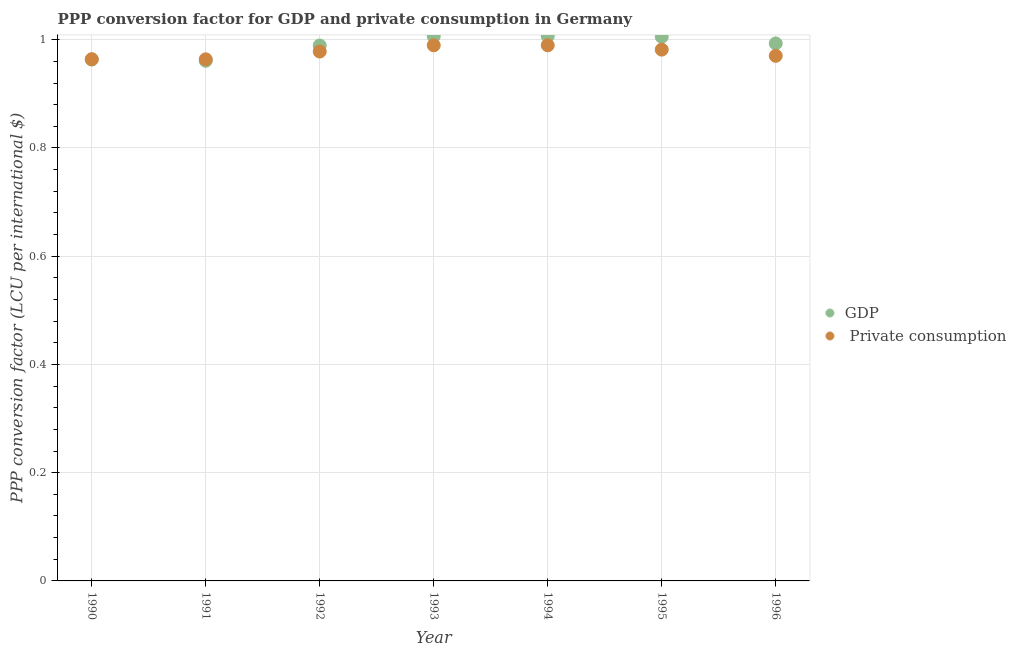How many different coloured dotlines are there?
Make the answer very short. 2. Is the number of dotlines equal to the number of legend labels?
Offer a terse response. Yes. What is the ppp conversion factor for private consumption in 1990?
Ensure brevity in your answer.  0.96. Across all years, what is the maximum ppp conversion factor for private consumption?
Offer a very short reply. 0.99. Across all years, what is the minimum ppp conversion factor for gdp?
Your response must be concise. 0.96. In which year was the ppp conversion factor for gdp maximum?
Provide a succinct answer. 1994. What is the total ppp conversion factor for gdp in the graph?
Your answer should be very brief. 6.93. What is the difference between the ppp conversion factor for private consumption in 1990 and that in 1996?
Provide a succinct answer. -0.01. What is the difference between the ppp conversion factor for private consumption in 1994 and the ppp conversion factor for gdp in 1990?
Offer a very short reply. 0.03. What is the average ppp conversion factor for gdp per year?
Ensure brevity in your answer.  0.99. In the year 1991, what is the difference between the ppp conversion factor for gdp and ppp conversion factor for private consumption?
Provide a succinct answer. -0. In how many years, is the ppp conversion factor for gdp greater than 0.6400000000000001 LCU?
Give a very brief answer. 7. What is the ratio of the ppp conversion factor for gdp in 1991 to that in 1993?
Offer a very short reply. 0.96. Is the difference between the ppp conversion factor for private consumption in 1993 and 1996 greater than the difference between the ppp conversion factor for gdp in 1993 and 1996?
Provide a succinct answer. Yes. What is the difference between the highest and the second highest ppp conversion factor for gdp?
Give a very brief answer. 0. What is the difference between the highest and the lowest ppp conversion factor for private consumption?
Offer a terse response. 0.03. In how many years, is the ppp conversion factor for gdp greater than the average ppp conversion factor for gdp taken over all years?
Give a very brief answer. 5. Does the ppp conversion factor for gdp monotonically increase over the years?
Provide a short and direct response. No. Is the ppp conversion factor for private consumption strictly greater than the ppp conversion factor for gdp over the years?
Keep it short and to the point. No. How many dotlines are there?
Keep it short and to the point. 2. How many years are there in the graph?
Provide a succinct answer. 7. Are the values on the major ticks of Y-axis written in scientific E-notation?
Make the answer very short. No. Does the graph contain any zero values?
Your answer should be very brief. No. Does the graph contain grids?
Your answer should be compact. Yes. How many legend labels are there?
Your answer should be very brief. 2. What is the title of the graph?
Your response must be concise. PPP conversion factor for GDP and private consumption in Germany. Does "Birth rate" appear as one of the legend labels in the graph?
Your answer should be very brief. No. What is the label or title of the X-axis?
Offer a terse response. Year. What is the label or title of the Y-axis?
Your answer should be compact. PPP conversion factor (LCU per international $). What is the PPP conversion factor (LCU per international $) in GDP in 1990?
Keep it short and to the point. 0.96. What is the PPP conversion factor (LCU per international $) of  Private consumption in 1990?
Make the answer very short. 0.96. What is the PPP conversion factor (LCU per international $) of GDP in 1991?
Keep it short and to the point. 0.96. What is the PPP conversion factor (LCU per international $) in  Private consumption in 1991?
Your answer should be very brief. 0.96. What is the PPP conversion factor (LCU per international $) in GDP in 1992?
Your answer should be very brief. 0.99. What is the PPP conversion factor (LCU per international $) of  Private consumption in 1992?
Your answer should be compact. 0.98. What is the PPP conversion factor (LCU per international $) of GDP in 1993?
Provide a short and direct response. 1.01. What is the PPP conversion factor (LCU per international $) in  Private consumption in 1993?
Make the answer very short. 0.99. What is the PPP conversion factor (LCU per international $) in GDP in 1994?
Make the answer very short. 1.01. What is the PPP conversion factor (LCU per international $) in  Private consumption in 1994?
Provide a short and direct response. 0.99. What is the PPP conversion factor (LCU per international $) of GDP in 1995?
Give a very brief answer. 1.01. What is the PPP conversion factor (LCU per international $) of  Private consumption in 1995?
Your answer should be very brief. 0.98. What is the PPP conversion factor (LCU per international $) of GDP in 1996?
Make the answer very short. 0.99. What is the PPP conversion factor (LCU per international $) in  Private consumption in 1996?
Offer a very short reply. 0.97. Across all years, what is the maximum PPP conversion factor (LCU per international $) in GDP?
Offer a very short reply. 1.01. Across all years, what is the maximum PPP conversion factor (LCU per international $) in  Private consumption?
Give a very brief answer. 0.99. Across all years, what is the minimum PPP conversion factor (LCU per international $) of GDP?
Offer a very short reply. 0.96. Across all years, what is the minimum PPP conversion factor (LCU per international $) of  Private consumption?
Offer a very short reply. 0.96. What is the total PPP conversion factor (LCU per international $) in GDP in the graph?
Offer a very short reply. 6.93. What is the total PPP conversion factor (LCU per international $) in  Private consumption in the graph?
Provide a short and direct response. 6.84. What is the difference between the PPP conversion factor (LCU per international $) of GDP in 1990 and that in 1991?
Provide a succinct answer. 0. What is the difference between the PPP conversion factor (LCU per international $) of GDP in 1990 and that in 1992?
Ensure brevity in your answer.  -0.03. What is the difference between the PPP conversion factor (LCU per international $) of  Private consumption in 1990 and that in 1992?
Your answer should be very brief. -0.01. What is the difference between the PPP conversion factor (LCU per international $) in GDP in 1990 and that in 1993?
Give a very brief answer. -0.04. What is the difference between the PPP conversion factor (LCU per international $) of  Private consumption in 1990 and that in 1993?
Make the answer very short. -0.03. What is the difference between the PPP conversion factor (LCU per international $) in GDP in 1990 and that in 1994?
Provide a succinct answer. -0.04. What is the difference between the PPP conversion factor (LCU per international $) of  Private consumption in 1990 and that in 1994?
Keep it short and to the point. -0.03. What is the difference between the PPP conversion factor (LCU per international $) in GDP in 1990 and that in 1995?
Offer a very short reply. -0.04. What is the difference between the PPP conversion factor (LCU per international $) of  Private consumption in 1990 and that in 1995?
Offer a terse response. -0.02. What is the difference between the PPP conversion factor (LCU per international $) in GDP in 1990 and that in 1996?
Your answer should be very brief. -0.03. What is the difference between the PPP conversion factor (LCU per international $) of  Private consumption in 1990 and that in 1996?
Provide a succinct answer. -0.01. What is the difference between the PPP conversion factor (LCU per international $) of GDP in 1991 and that in 1992?
Your answer should be very brief. -0.03. What is the difference between the PPP conversion factor (LCU per international $) of  Private consumption in 1991 and that in 1992?
Make the answer very short. -0.01. What is the difference between the PPP conversion factor (LCU per international $) of GDP in 1991 and that in 1993?
Make the answer very short. -0.05. What is the difference between the PPP conversion factor (LCU per international $) in  Private consumption in 1991 and that in 1993?
Your answer should be very brief. -0.03. What is the difference between the PPP conversion factor (LCU per international $) in GDP in 1991 and that in 1994?
Keep it short and to the point. -0.05. What is the difference between the PPP conversion factor (LCU per international $) of  Private consumption in 1991 and that in 1994?
Make the answer very short. -0.03. What is the difference between the PPP conversion factor (LCU per international $) of GDP in 1991 and that in 1995?
Give a very brief answer. -0.04. What is the difference between the PPP conversion factor (LCU per international $) of  Private consumption in 1991 and that in 1995?
Keep it short and to the point. -0.02. What is the difference between the PPP conversion factor (LCU per international $) of GDP in 1991 and that in 1996?
Offer a terse response. -0.03. What is the difference between the PPP conversion factor (LCU per international $) in  Private consumption in 1991 and that in 1996?
Offer a very short reply. -0.01. What is the difference between the PPP conversion factor (LCU per international $) of GDP in 1992 and that in 1993?
Give a very brief answer. -0.02. What is the difference between the PPP conversion factor (LCU per international $) of  Private consumption in 1992 and that in 1993?
Provide a succinct answer. -0.01. What is the difference between the PPP conversion factor (LCU per international $) in GDP in 1992 and that in 1994?
Give a very brief answer. -0.02. What is the difference between the PPP conversion factor (LCU per international $) of  Private consumption in 1992 and that in 1994?
Your response must be concise. -0.01. What is the difference between the PPP conversion factor (LCU per international $) of GDP in 1992 and that in 1995?
Provide a succinct answer. -0.02. What is the difference between the PPP conversion factor (LCU per international $) in  Private consumption in 1992 and that in 1995?
Provide a short and direct response. -0. What is the difference between the PPP conversion factor (LCU per international $) of GDP in 1992 and that in 1996?
Offer a terse response. -0. What is the difference between the PPP conversion factor (LCU per international $) in  Private consumption in 1992 and that in 1996?
Give a very brief answer. 0.01. What is the difference between the PPP conversion factor (LCU per international $) of GDP in 1993 and that in 1994?
Give a very brief answer. -0. What is the difference between the PPP conversion factor (LCU per international $) of  Private consumption in 1993 and that in 1994?
Offer a very short reply. -0. What is the difference between the PPP conversion factor (LCU per international $) of GDP in 1993 and that in 1995?
Offer a very short reply. 0. What is the difference between the PPP conversion factor (LCU per international $) of  Private consumption in 1993 and that in 1995?
Provide a short and direct response. 0.01. What is the difference between the PPP conversion factor (LCU per international $) in GDP in 1993 and that in 1996?
Ensure brevity in your answer.  0.01. What is the difference between the PPP conversion factor (LCU per international $) of  Private consumption in 1993 and that in 1996?
Your answer should be very brief. 0.02. What is the difference between the PPP conversion factor (LCU per international $) of GDP in 1994 and that in 1995?
Offer a terse response. 0. What is the difference between the PPP conversion factor (LCU per international $) of  Private consumption in 1994 and that in 1995?
Give a very brief answer. 0.01. What is the difference between the PPP conversion factor (LCU per international $) of GDP in 1994 and that in 1996?
Offer a very short reply. 0.01. What is the difference between the PPP conversion factor (LCU per international $) in  Private consumption in 1994 and that in 1996?
Offer a terse response. 0.02. What is the difference between the PPP conversion factor (LCU per international $) of GDP in 1995 and that in 1996?
Ensure brevity in your answer.  0.01. What is the difference between the PPP conversion factor (LCU per international $) of  Private consumption in 1995 and that in 1996?
Make the answer very short. 0.01. What is the difference between the PPP conversion factor (LCU per international $) in GDP in 1990 and the PPP conversion factor (LCU per international $) in  Private consumption in 1991?
Ensure brevity in your answer.  -0. What is the difference between the PPP conversion factor (LCU per international $) in GDP in 1990 and the PPP conversion factor (LCU per international $) in  Private consumption in 1992?
Offer a very short reply. -0.01. What is the difference between the PPP conversion factor (LCU per international $) of GDP in 1990 and the PPP conversion factor (LCU per international $) of  Private consumption in 1993?
Give a very brief answer. -0.03. What is the difference between the PPP conversion factor (LCU per international $) in GDP in 1990 and the PPP conversion factor (LCU per international $) in  Private consumption in 1994?
Keep it short and to the point. -0.03. What is the difference between the PPP conversion factor (LCU per international $) of GDP in 1990 and the PPP conversion factor (LCU per international $) of  Private consumption in 1995?
Provide a succinct answer. -0.02. What is the difference between the PPP conversion factor (LCU per international $) in GDP in 1990 and the PPP conversion factor (LCU per international $) in  Private consumption in 1996?
Give a very brief answer. -0.01. What is the difference between the PPP conversion factor (LCU per international $) of GDP in 1991 and the PPP conversion factor (LCU per international $) of  Private consumption in 1992?
Your response must be concise. -0.02. What is the difference between the PPP conversion factor (LCU per international $) of GDP in 1991 and the PPP conversion factor (LCU per international $) of  Private consumption in 1993?
Offer a very short reply. -0.03. What is the difference between the PPP conversion factor (LCU per international $) in GDP in 1991 and the PPP conversion factor (LCU per international $) in  Private consumption in 1994?
Give a very brief answer. -0.03. What is the difference between the PPP conversion factor (LCU per international $) of GDP in 1991 and the PPP conversion factor (LCU per international $) of  Private consumption in 1995?
Make the answer very short. -0.02. What is the difference between the PPP conversion factor (LCU per international $) in GDP in 1991 and the PPP conversion factor (LCU per international $) in  Private consumption in 1996?
Your answer should be very brief. -0.01. What is the difference between the PPP conversion factor (LCU per international $) of GDP in 1992 and the PPP conversion factor (LCU per international $) of  Private consumption in 1993?
Your answer should be compact. -0. What is the difference between the PPP conversion factor (LCU per international $) of GDP in 1992 and the PPP conversion factor (LCU per international $) of  Private consumption in 1994?
Your response must be concise. -0. What is the difference between the PPP conversion factor (LCU per international $) of GDP in 1992 and the PPP conversion factor (LCU per international $) of  Private consumption in 1995?
Make the answer very short. 0.01. What is the difference between the PPP conversion factor (LCU per international $) in GDP in 1992 and the PPP conversion factor (LCU per international $) in  Private consumption in 1996?
Make the answer very short. 0.02. What is the difference between the PPP conversion factor (LCU per international $) of GDP in 1993 and the PPP conversion factor (LCU per international $) of  Private consumption in 1994?
Offer a terse response. 0.02. What is the difference between the PPP conversion factor (LCU per international $) of GDP in 1993 and the PPP conversion factor (LCU per international $) of  Private consumption in 1995?
Ensure brevity in your answer.  0.02. What is the difference between the PPP conversion factor (LCU per international $) of GDP in 1993 and the PPP conversion factor (LCU per international $) of  Private consumption in 1996?
Your answer should be very brief. 0.04. What is the difference between the PPP conversion factor (LCU per international $) in GDP in 1994 and the PPP conversion factor (LCU per international $) in  Private consumption in 1995?
Ensure brevity in your answer.  0.03. What is the difference between the PPP conversion factor (LCU per international $) in GDP in 1994 and the PPP conversion factor (LCU per international $) in  Private consumption in 1996?
Your answer should be compact. 0.04. What is the difference between the PPP conversion factor (LCU per international $) of GDP in 1995 and the PPP conversion factor (LCU per international $) of  Private consumption in 1996?
Your answer should be compact. 0.04. What is the average PPP conversion factor (LCU per international $) in GDP per year?
Your response must be concise. 0.99. What is the average PPP conversion factor (LCU per international $) in  Private consumption per year?
Ensure brevity in your answer.  0.98. In the year 1990, what is the difference between the PPP conversion factor (LCU per international $) of GDP and PPP conversion factor (LCU per international $) of  Private consumption?
Your response must be concise. -0. In the year 1991, what is the difference between the PPP conversion factor (LCU per international $) in GDP and PPP conversion factor (LCU per international $) in  Private consumption?
Your response must be concise. -0. In the year 1992, what is the difference between the PPP conversion factor (LCU per international $) in GDP and PPP conversion factor (LCU per international $) in  Private consumption?
Your response must be concise. 0.01. In the year 1993, what is the difference between the PPP conversion factor (LCU per international $) of GDP and PPP conversion factor (LCU per international $) of  Private consumption?
Your response must be concise. 0.02. In the year 1994, what is the difference between the PPP conversion factor (LCU per international $) of GDP and PPP conversion factor (LCU per international $) of  Private consumption?
Offer a very short reply. 0.02. In the year 1995, what is the difference between the PPP conversion factor (LCU per international $) in GDP and PPP conversion factor (LCU per international $) in  Private consumption?
Ensure brevity in your answer.  0.02. In the year 1996, what is the difference between the PPP conversion factor (LCU per international $) in GDP and PPP conversion factor (LCU per international $) in  Private consumption?
Provide a succinct answer. 0.02. What is the ratio of the PPP conversion factor (LCU per international $) in GDP in 1990 to that in 1991?
Ensure brevity in your answer.  1. What is the ratio of the PPP conversion factor (LCU per international $) in  Private consumption in 1990 to that in 1991?
Keep it short and to the point. 1. What is the ratio of the PPP conversion factor (LCU per international $) of GDP in 1990 to that in 1992?
Make the answer very short. 0.97. What is the ratio of the PPP conversion factor (LCU per international $) of  Private consumption in 1990 to that in 1992?
Your answer should be compact. 0.99. What is the ratio of the PPP conversion factor (LCU per international $) of GDP in 1990 to that in 1993?
Your response must be concise. 0.96. What is the ratio of the PPP conversion factor (LCU per international $) in  Private consumption in 1990 to that in 1993?
Your answer should be very brief. 0.97. What is the ratio of the PPP conversion factor (LCU per international $) in GDP in 1990 to that in 1994?
Your response must be concise. 0.96. What is the ratio of the PPP conversion factor (LCU per international $) in GDP in 1990 to that in 1995?
Provide a succinct answer. 0.96. What is the ratio of the PPP conversion factor (LCU per international $) of  Private consumption in 1990 to that in 1995?
Ensure brevity in your answer.  0.98. What is the ratio of the PPP conversion factor (LCU per international $) in GDP in 1990 to that in 1996?
Provide a short and direct response. 0.97. What is the ratio of the PPP conversion factor (LCU per international $) of GDP in 1991 to that in 1992?
Your response must be concise. 0.97. What is the ratio of the PPP conversion factor (LCU per international $) in GDP in 1991 to that in 1993?
Offer a terse response. 0.95. What is the ratio of the PPP conversion factor (LCU per international $) of  Private consumption in 1991 to that in 1993?
Offer a terse response. 0.97. What is the ratio of the PPP conversion factor (LCU per international $) in GDP in 1991 to that in 1994?
Make the answer very short. 0.95. What is the ratio of the PPP conversion factor (LCU per international $) in  Private consumption in 1991 to that in 1994?
Offer a terse response. 0.97. What is the ratio of the PPP conversion factor (LCU per international $) in GDP in 1991 to that in 1995?
Provide a short and direct response. 0.96. What is the ratio of the PPP conversion factor (LCU per international $) of  Private consumption in 1991 to that in 1995?
Keep it short and to the point. 0.98. What is the ratio of the PPP conversion factor (LCU per international $) of GDP in 1991 to that in 1996?
Ensure brevity in your answer.  0.97. What is the ratio of the PPP conversion factor (LCU per international $) of GDP in 1992 to that in 1993?
Offer a terse response. 0.98. What is the ratio of the PPP conversion factor (LCU per international $) in  Private consumption in 1992 to that in 1993?
Offer a terse response. 0.99. What is the ratio of the PPP conversion factor (LCU per international $) in GDP in 1992 to that in 1994?
Provide a short and direct response. 0.98. What is the ratio of the PPP conversion factor (LCU per international $) in  Private consumption in 1992 to that in 1994?
Provide a succinct answer. 0.99. What is the ratio of the PPP conversion factor (LCU per international $) in GDP in 1992 to that in 1995?
Offer a terse response. 0.98. What is the ratio of the PPP conversion factor (LCU per international $) of  Private consumption in 1992 to that in 1995?
Provide a short and direct response. 1. What is the ratio of the PPP conversion factor (LCU per international $) in  Private consumption in 1992 to that in 1996?
Offer a very short reply. 1.01. What is the ratio of the PPP conversion factor (LCU per international $) in  Private consumption in 1993 to that in 1994?
Ensure brevity in your answer.  1. What is the ratio of the PPP conversion factor (LCU per international $) of GDP in 1993 to that in 1996?
Make the answer very short. 1.01. What is the ratio of the PPP conversion factor (LCU per international $) of  Private consumption in 1993 to that in 1996?
Offer a terse response. 1.02. What is the ratio of the PPP conversion factor (LCU per international $) of GDP in 1994 to that in 1995?
Give a very brief answer. 1. What is the ratio of the PPP conversion factor (LCU per international $) of  Private consumption in 1994 to that in 1995?
Offer a terse response. 1.01. What is the ratio of the PPP conversion factor (LCU per international $) of GDP in 1994 to that in 1996?
Provide a short and direct response. 1.01. What is the ratio of the PPP conversion factor (LCU per international $) of  Private consumption in 1994 to that in 1996?
Offer a terse response. 1.02. What is the ratio of the PPP conversion factor (LCU per international $) in GDP in 1995 to that in 1996?
Your answer should be compact. 1.01. What is the ratio of the PPP conversion factor (LCU per international $) in  Private consumption in 1995 to that in 1996?
Your answer should be very brief. 1.01. What is the difference between the highest and the lowest PPP conversion factor (LCU per international $) of GDP?
Your response must be concise. 0.05. What is the difference between the highest and the lowest PPP conversion factor (LCU per international $) in  Private consumption?
Give a very brief answer. 0.03. 